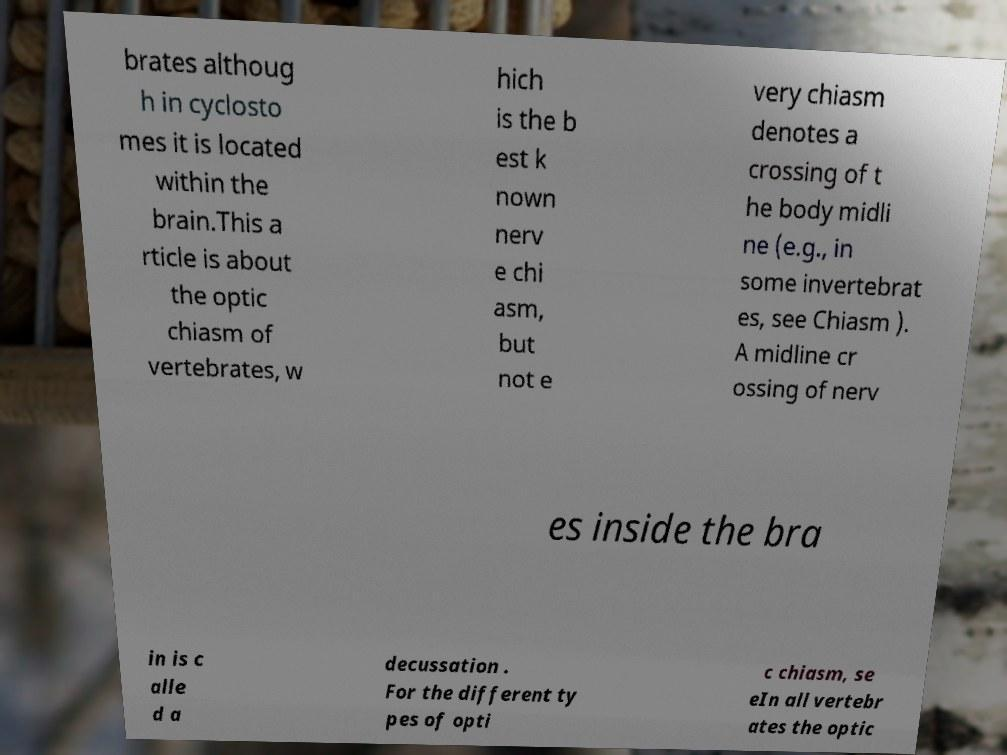Could you extract and type out the text from this image? brates althoug h in cyclosto mes it is located within the brain.This a rticle is about the optic chiasm of vertebrates, w hich is the b est k nown nerv e chi asm, but not e very chiasm denotes a crossing of t he body midli ne (e.g., in some invertebrat es, see Chiasm ). A midline cr ossing of nerv es inside the bra in is c alle d a decussation . For the different ty pes of opti c chiasm, se eIn all vertebr ates the optic 